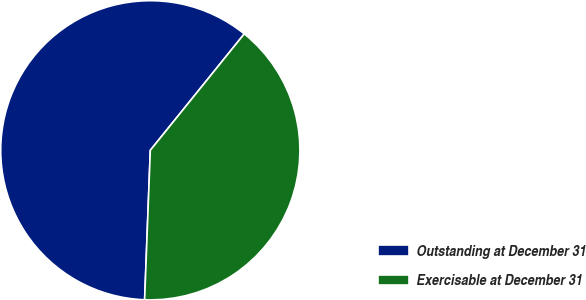<chart> <loc_0><loc_0><loc_500><loc_500><pie_chart><fcel>Outstanding at December 31<fcel>Exercisable at December 31<nl><fcel>60.2%<fcel>39.8%<nl></chart> 